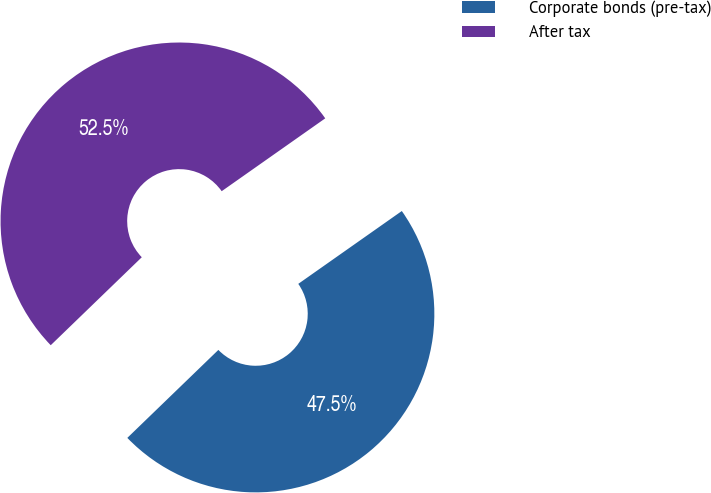<chart> <loc_0><loc_0><loc_500><loc_500><pie_chart><fcel>Corporate bonds (pre-tax)<fcel>After tax<nl><fcel>47.53%<fcel>52.47%<nl></chart> 